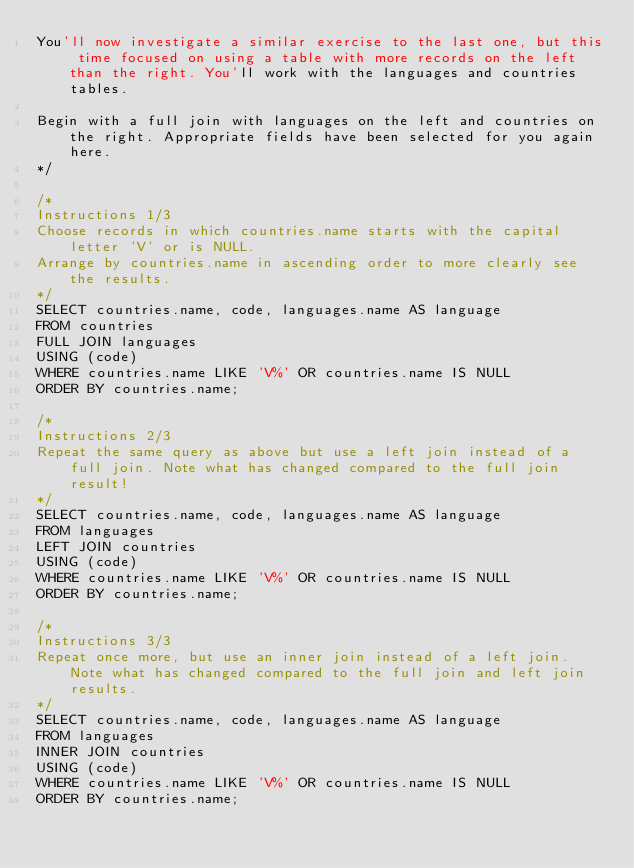<code> <loc_0><loc_0><loc_500><loc_500><_SQL_>You'll now investigate a similar exercise to the last one, but this time focused on using a table with more records on the left than the right. You'll work with the languages and countries tables.

Begin with a full join with languages on the left and countries on the right. Appropriate fields have been selected for you again here.
*/

/*
Instructions 1/3
Choose records in which countries.name starts with the capital letter 'V' or is NULL.
Arrange by countries.name in ascending order to more clearly see the results.
*/
SELECT countries.name, code, languages.name AS language
FROM countries
FULL JOIN languages
USING (code)
WHERE countries.name LIKE 'V%' OR countries.name IS NULL
ORDER BY countries.name;

/*
Instructions 2/3
Repeat the same query as above but use a left join instead of a full join. Note what has changed compared to the full join result!
*/
SELECT countries.name, code, languages.name AS language
FROM languages
LEFT JOIN countries
USING (code)
WHERE countries.name LIKE 'V%' OR countries.name IS NULL
ORDER BY countries.name;

/*
Instructions 3/3
Repeat once more, but use an inner join instead of a left join. Note what has changed compared to the full join and left join results.
*/
SELECT countries.name, code, languages.name AS language
FROM languages
INNER JOIN countries
USING (code)
WHERE countries.name LIKE 'V%' OR countries.name IS NULL
ORDER BY countries.name;</code> 